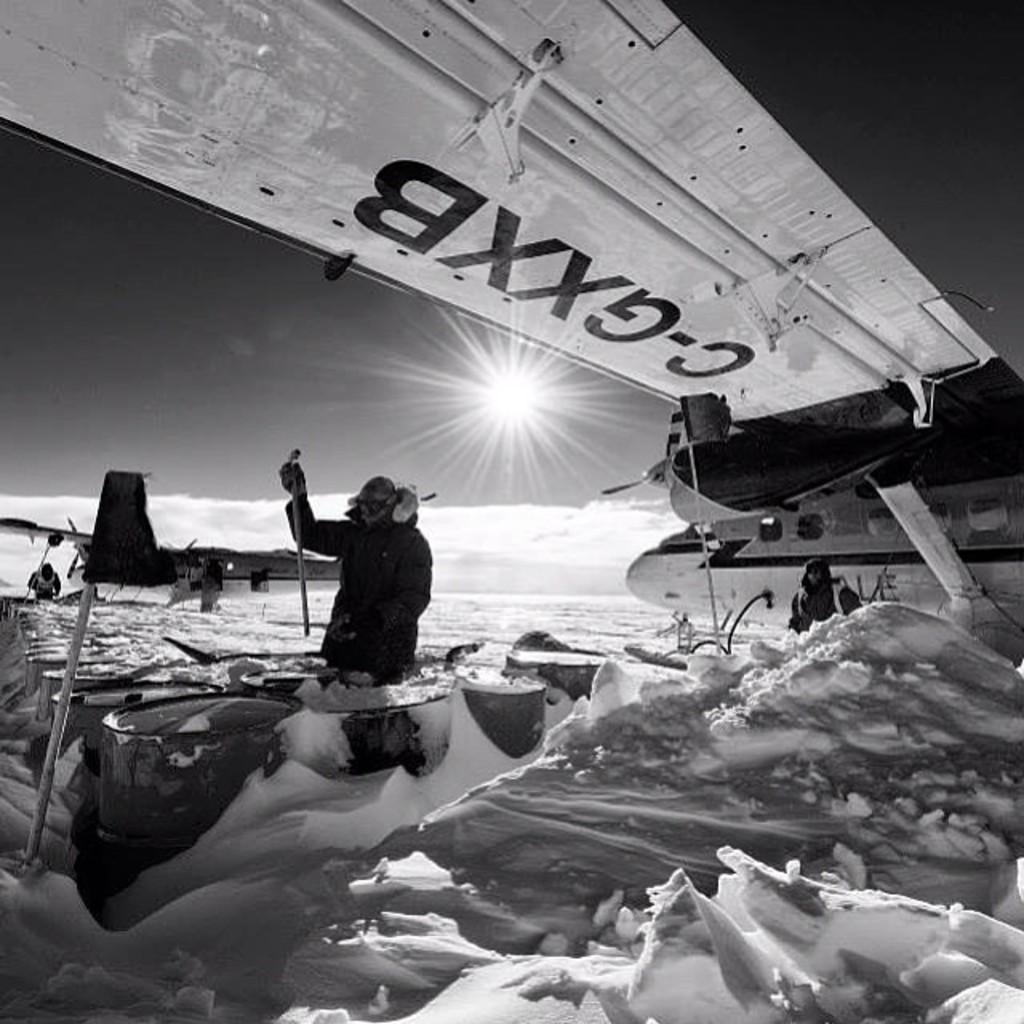<image>
Describe the image concisely. a man sitting underneath a airplane wing with the letters c-gxxb on it. 